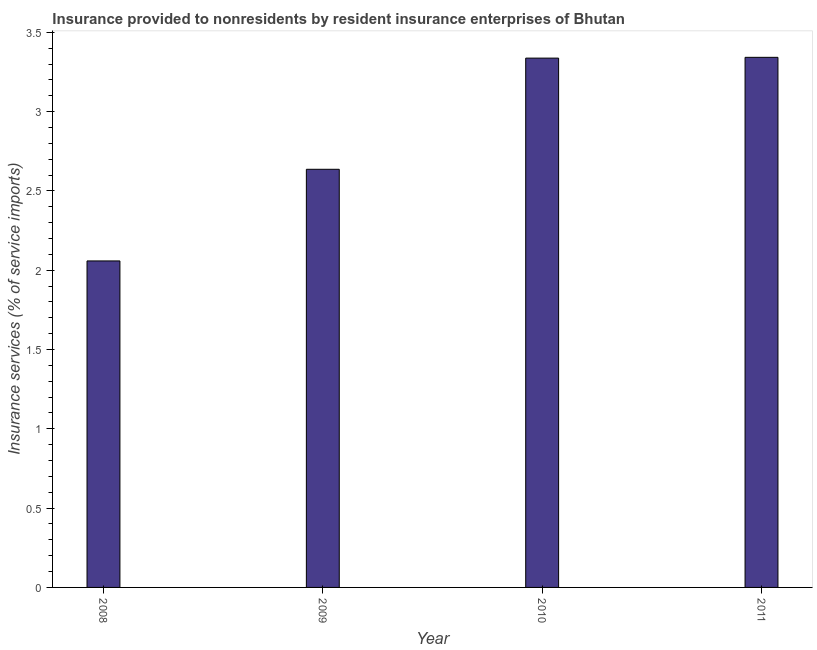Does the graph contain any zero values?
Provide a short and direct response. No. Does the graph contain grids?
Offer a terse response. No. What is the title of the graph?
Your answer should be very brief. Insurance provided to nonresidents by resident insurance enterprises of Bhutan. What is the label or title of the Y-axis?
Offer a terse response. Insurance services (% of service imports). What is the insurance and financial services in 2009?
Your answer should be very brief. 2.64. Across all years, what is the maximum insurance and financial services?
Offer a very short reply. 3.34. Across all years, what is the minimum insurance and financial services?
Keep it short and to the point. 2.06. In which year was the insurance and financial services maximum?
Make the answer very short. 2011. In which year was the insurance and financial services minimum?
Offer a very short reply. 2008. What is the sum of the insurance and financial services?
Keep it short and to the point. 11.38. What is the difference between the insurance and financial services in 2009 and 2010?
Your answer should be very brief. -0.7. What is the average insurance and financial services per year?
Provide a short and direct response. 2.84. What is the median insurance and financial services?
Provide a short and direct response. 2.99. In how many years, is the insurance and financial services greater than 0.6 %?
Your answer should be very brief. 4. What is the ratio of the insurance and financial services in 2009 to that in 2011?
Give a very brief answer. 0.79. What is the difference between the highest and the second highest insurance and financial services?
Give a very brief answer. 0.01. What is the difference between the highest and the lowest insurance and financial services?
Your answer should be compact. 1.28. How many bars are there?
Your answer should be very brief. 4. Are all the bars in the graph horizontal?
Provide a short and direct response. No. How many years are there in the graph?
Offer a very short reply. 4. What is the difference between two consecutive major ticks on the Y-axis?
Give a very brief answer. 0.5. Are the values on the major ticks of Y-axis written in scientific E-notation?
Keep it short and to the point. No. What is the Insurance services (% of service imports) in 2008?
Make the answer very short. 2.06. What is the Insurance services (% of service imports) in 2009?
Your response must be concise. 2.64. What is the Insurance services (% of service imports) in 2010?
Keep it short and to the point. 3.34. What is the Insurance services (% of service imports) in 2011?
Ensure brevity in your answer.  3.34. What is the difference between the Insurance services (% of service imports) in 2008 and 2009?
Keep it short and to the point. -0.58. What is the difference between the Insurance services (% of service imports) in 2008 and 2010?
Offer a very short reply. -1.28. What is the difference between the Insurance services (% of service imports) in 2008 and 2011?
Offer a very short reply. -1.28. What is the difference between the Insurance services (% of service imports) in 2009 and 2010?
Keep it short and to the point. -0.7. What is the difference between the Insurance services (% of service imports) in 2009 and 2011?
Your answer should be very brief. -0.71. What is the difference between the Insurance services (% of service imports) in 2010 and 2011?
Your answer should be very brief. -0. What is the ratio of the Insurance services (% of service imports) in 2008 to that in 2009?
Offer a terse response. 0.78. What is the ratio of the Insurance services (% of service imports) in 2008 to that in 2010?
Offer a terse response. 0.62. What is the ratio of the Insurance services (% of service imports) in 2008 to that in 2011?
Provide a short and direct response. 0.62. What is the ratio of the Insurance services (% of service imports) in 2009 to that in 2010?
Your response must be concise. 0.79. What is the ratio of the Insurance services (% of service imports) in 2009 to that in 2011?
Keep it short and to the point. 0.79. 